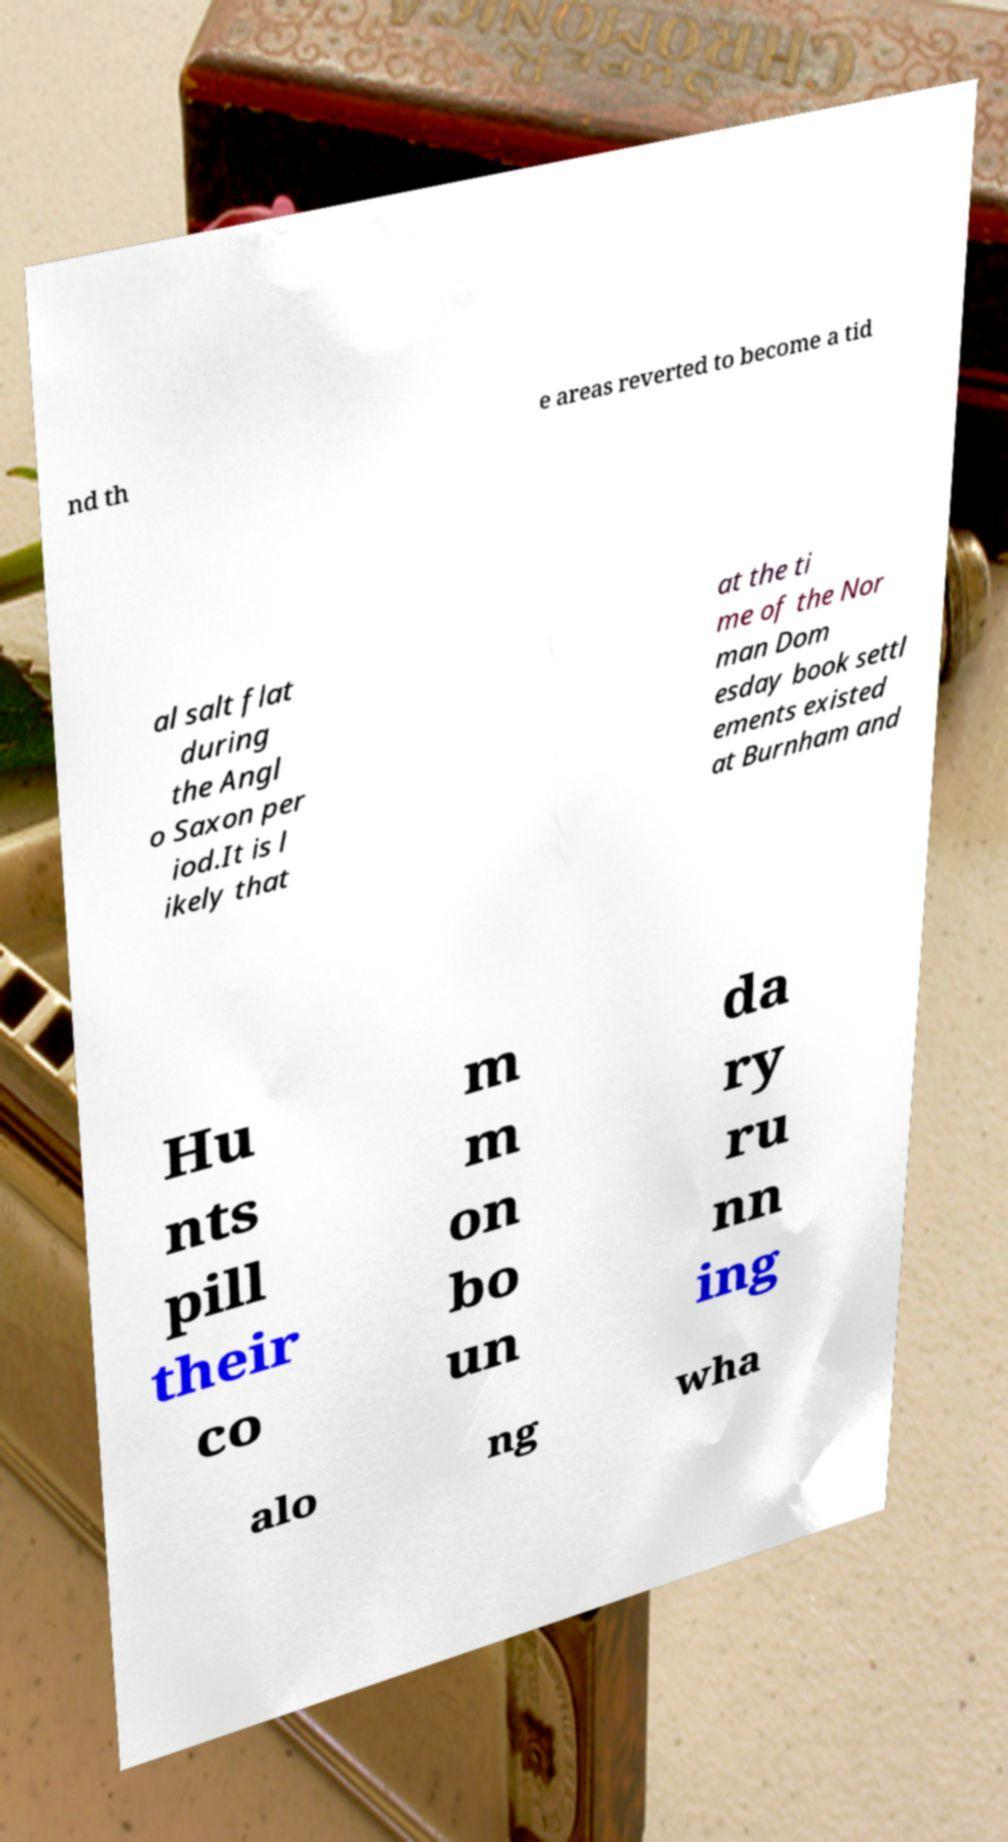Can you accurately transcribe the text from the provided image for me? nd th e areas reverted to become a tid al salt flat during the Angl o Saxon per iod.It is l ikely that at the ti me of the Nor man Dom esday book settl ements existed at Burnham and Hu nts pill their co m m on bo un da ry ru nn ing alo ng wha 